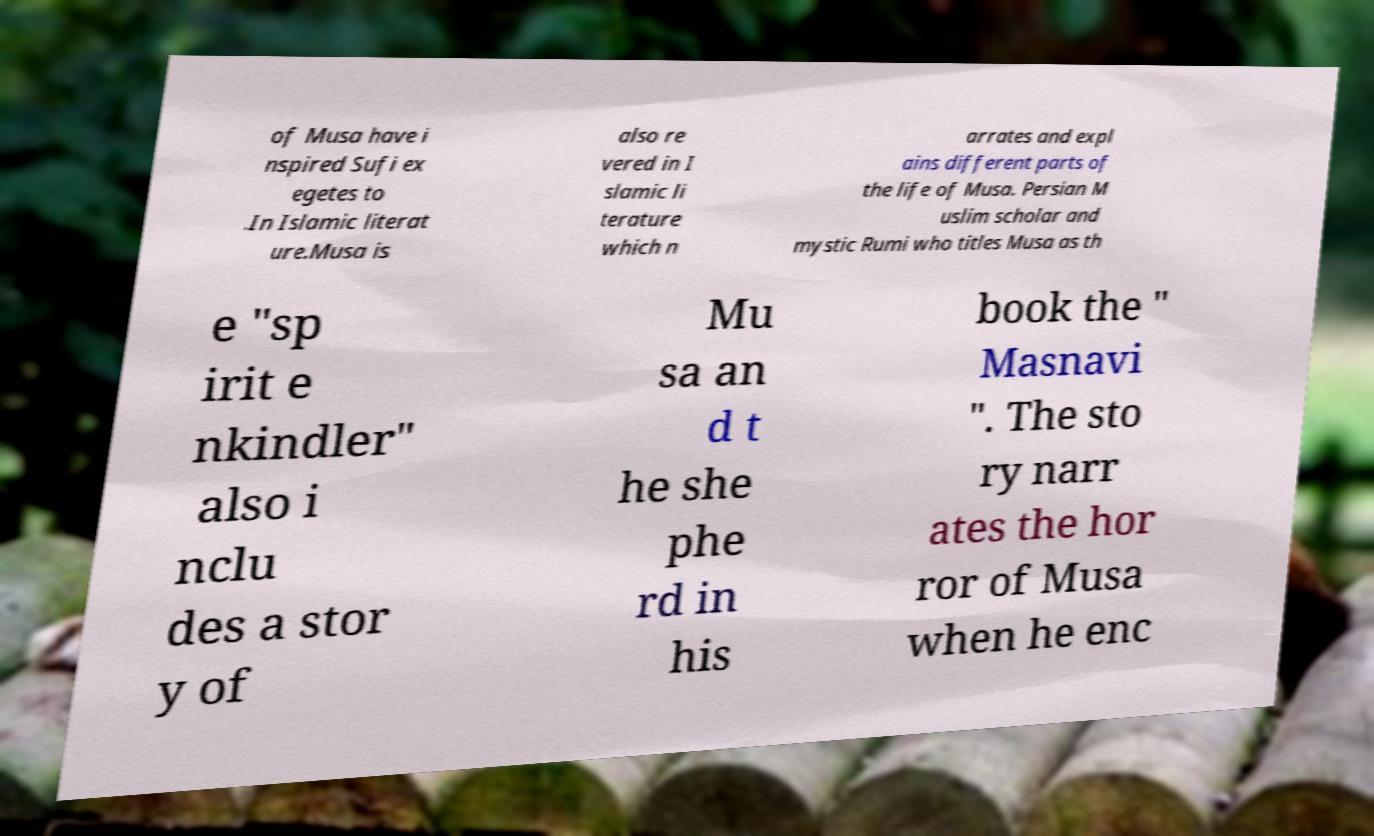Can you accurately transcribe the text from the provided image for me? of Musa have i nspired Sufi ex egetes to .In Islamic literat ure.Musa is also re vered in I slamic li terature which n arrates and expl ains different parts of the life of Musa. Persian M uslim scholar and mystic Rumi who titles Musa as th e "sp irit e nkindler" also i nclu des a stor y of Mu sa an d t he she phe rd in his book the " Masnavi ". The sto ry narr ates the hor ror of Musa when he enc 